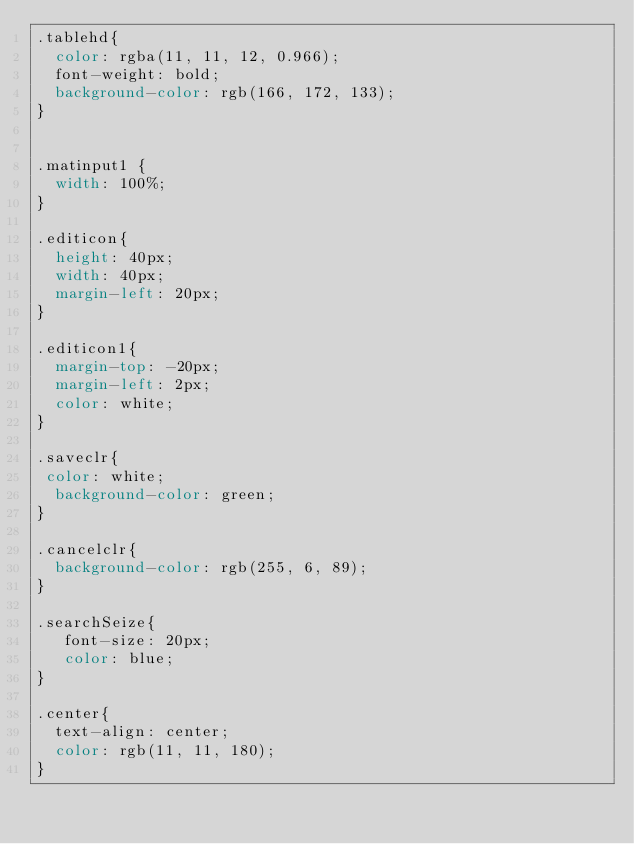Convert code to text. <code><loc_0><loc_0><loc_500><loc_500><_CSS_>.tablehd{
  color: rgba(11, 11, 12, 0.966);
  font-weight: bold;
  background-color: rgb(166, 172, 133);
}


.matinput1 {
  width: 100%;
}

.editicon{
  height: 40px;
  width: 40px;
  margin-left: 20px;
}

.editicon1{
  margin-top: -20px;
  margin-left: 2px;
  color: white;
}

.saveclr{
 color: white;
  background-color: green;
}

.cancelclr{
  background-color: rgb(255, 6, 89);
}

.searchSeize{
   font-size: 20px;
   color: blue;
}

.center{
  text-align: center;
  color: rgb(11, 11, 180);
}



</code> 